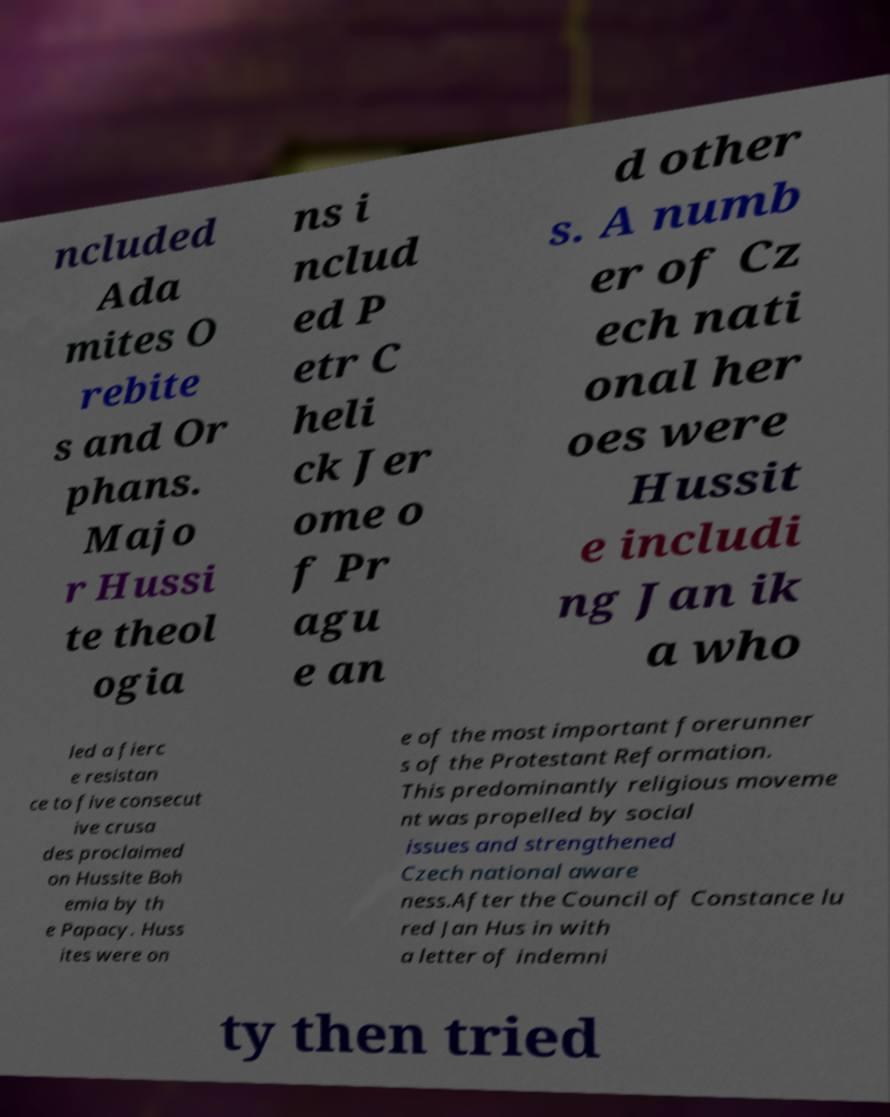There's text embedded in this image that I need extracted. Can you transcribe it verbatim? ncluded Ada mites O rebite s and Or phans. Majo r Hussi te theol ogia ns i nclud ed P etr C heli ck Jer ome o f Pr agu e an d other s. A numb er of Cz ech nati onal her oes were Hussit e includi ng Jan ik a who led a fierc e resistan ce to five consecut ive crusa des proclaimed on Hussite Boh emia by th e Papacy. Huss ites were on e of the most important forerunner s of the Protestant Reformation. This predominantly religious moveme nt was propelled by social issues and strengthened Czech national aware ness.After the Council of Constance lu red Jan Hus in with a letter of indemni ty then tried 